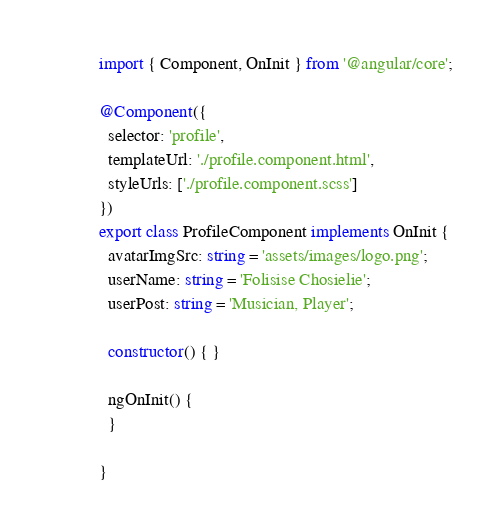Convert code to text. <code><loc_0><loc_0><loc_500><loc_500><_TypeScript_>import { Component, OnInit } from '@angular/core';

@Component({
  selector: 'profile',
  templateUrl: './profile.component.html',
  styleUrls: ['./profile.component.scss']
})
export class ProfileComponent implements OnInit {
  avatarImgSrc: string = 'assets/images/logo.png';
  userName: string = 'Folisise Chosielie';
  userPost: string = 'Musician, Player';
  
  constructor() { }

  ngOnInit() {
  }

}
</code> 